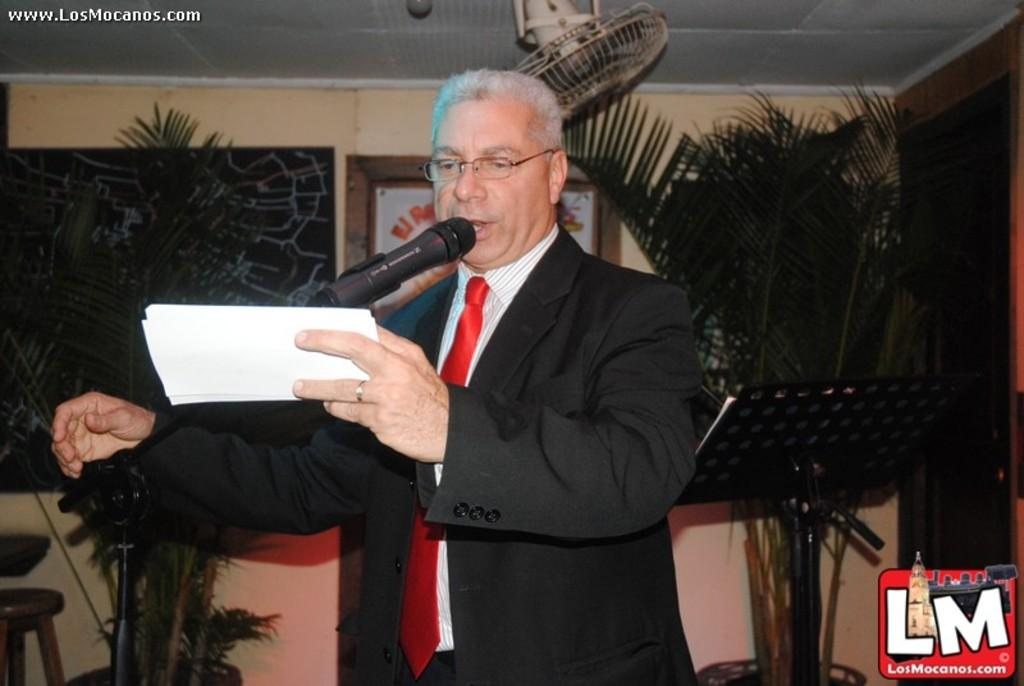What is the person in the image holding? The person is standing with a paper in the image. What can be seen in the background of the image? There is a board, plants, a fan, a photo frame, and a wall in the background of the image. Can you describe the wall in the background? The wall is in the background of the image. How many books are visible on the wall in the image? There are no books visible on the wall in the image. What type of memory does the person have in the image? The person does not have a memory in the image; they are holding a paper. 